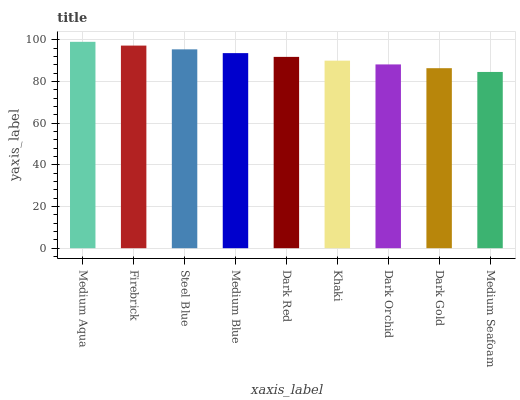Is Firebrick the minimum?
Answer yes or no. No. Is Firebrick the maximum?
Answer yes or no. No. Is Medium Aqua greater than Firebrick?
Answer yes or no. Yes. Is Firebrick less than Medium Aqua?
Answer yes or no. Yes. Is Firebrick greater than Medium Aqua?
Answer yes or no. No. Is Medium Aqua less than Firebrick?
Answer yes or no. No. Is Dark Red the high median?
Answer yes or no. Yes. Is Dark Red the low median?
Answer yes or no. Yes. Is Firebrick the high median?
Answer yes or no. No. Is Dark Orchid the low median?
Answer yes or no. No. 